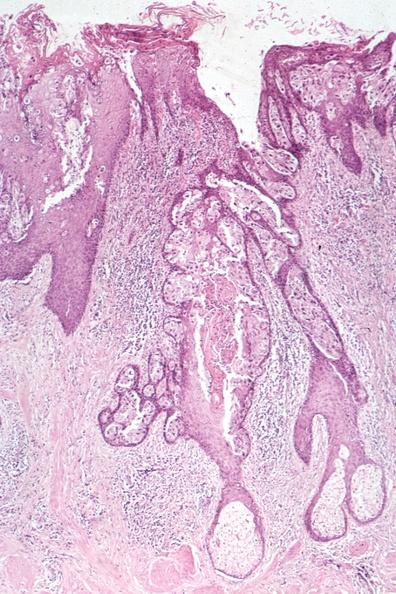s carcinoma present?
Answer the question using a single word or phrase. Yes 